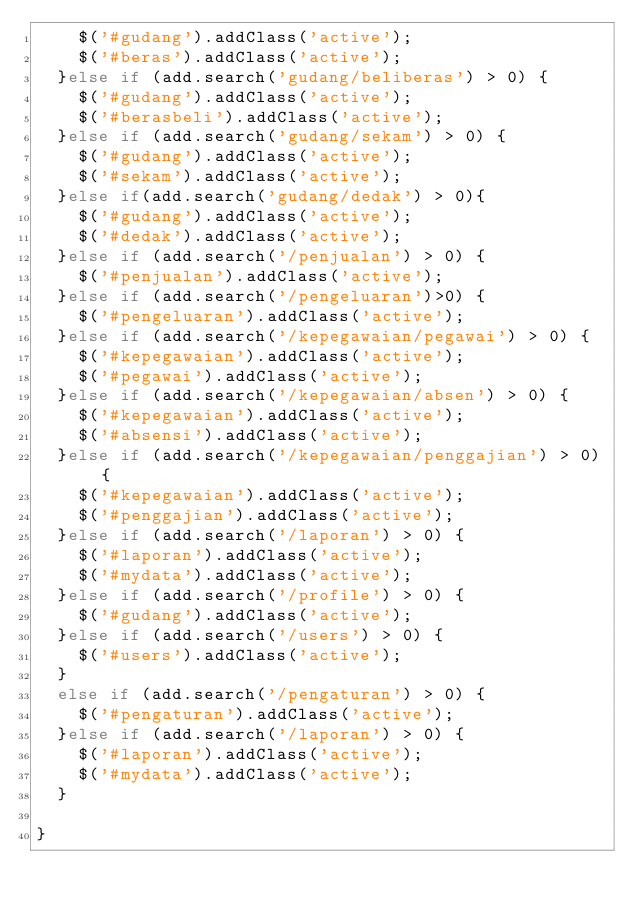Convert code to text. <code><loc_0><loc_0><loc_500><loc_500><_JavaScript_>    $('#gudang').addClass('active');
    $('#beras').addClass('active');
  }else if (add.search('gudang/beliberas') > 0) {
    $('#gudang').addClass('active');
    $('#berasbeli').addClass('active');
  }else if (add.search('gudang/sekam') > 0) {
    $('#gudang').addClass('active');
    $('#sekam').addClass('active');
  }else if(add.search('gudang/dedak') > 0){
    $('#gudang').addClass('active');
    $('#dedak').addClass('active');
  }else if (add.search('/penjualan') > 0) {
    $('#penjualan').addClass('active');
  }else if (add.search('/pengeluaran')>0) {
    $('#pengeluaran').addClass('active');
  }else if (add.search('/kepegawaian/pegawai') > 0) {
    $('#kepegawaian').addClass('active');
    $('#pegawai').addClass('active');
  }else if (add.search('/kepegawaian/absen') > 0) {
    $('#kepegawaian').addClass('active');
    $('#absensi').addClass('active');
  }else if (add.search('/kepegawaian/penggajian') > 0) {
    $('#kepegawaian').addClass('active');
    $('#penggajian').addClass('active');
  }else if (add.search('/laporan') > 0) {
    $('#laporan').addClass('active');
    $('#mydata').addClass('active');
  }else if (add.search('/profile') > 0) {
    $('#gudang').addClass('active');
  }else if (add.search('/users') > 0) {
    $('#users').addClass('active');
  }
  else if (add.search('/pengaturan') > 0) {
    $('#pengaturan').addClass('active');
  }else if (add.search('/laporan') > 0) {
    $('#laporan').addClass('active');
    $('#mydata').addClass('active');
  }

}
</code> 